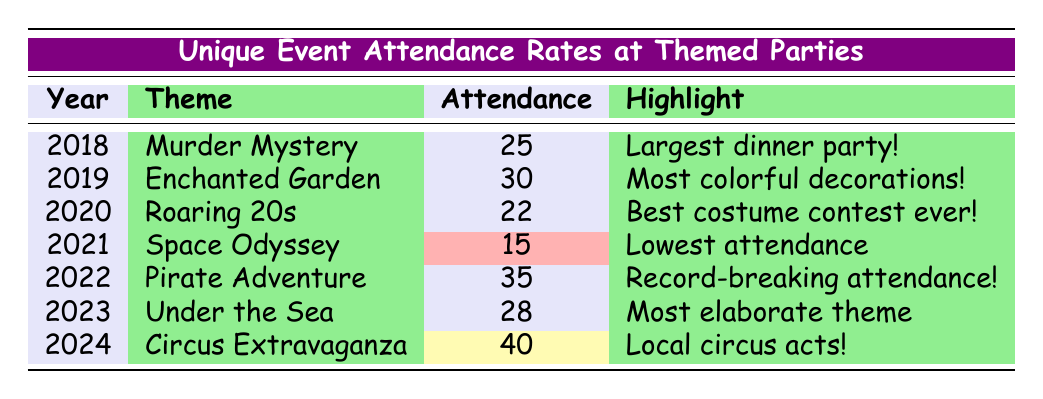What was the attendance at Aunt Margie's Enchanted Soirée in 2019? The table lists the attendance for the event "Aunt Margie's Enchanted Soirée" in the year 2019, which is 30.
Answer: 30 Which themed party had the lowest attendance? The "Space Odyssey" themed party in 2021 had the lowest attendance with a count of 15, which is highlighted in red.
Answer: 15 What is the total attendance for the themed parties from 2018 to 2022? To find the total attendance, we add the attendees: 25 (2018) + 30 (2019) + 22 (2020) + 15 (2021) + 35 (2022) = 127.
Answer: 127 Did the attendance increase or decrease from the "Great Gatsby Gatsby Night" to the "Mermaid Masquerade"? "Great Gatsby Gatsby Night" had 22 attendees and "Mermaid Masquerade" had 28 attendees. The attendance increased from 22 to 28.
Answer: Increase What was the average attendance from the events listed from 2018 to 2024? Add the attendance figures: 25 + 30 + 22 + 15 + 35 + 28 + 40 = 195. There are 7 events, so the average attendance is 195 / 7 ≈ 27.857, which rounds to approximately 28.
Answer: 28 Which themed party had the highest attendance and what was the specific number? The "Circus Extravaganza" in 2024 had the highest attendance with 40, which is highlighted in yellow.
Answer: 40 Was there any event in the table that had an attendance less than 20? Checking the attendance figures: the lowest is 15 for the "Space Odyssey" theme, confirming that there is an event with attendance less than 20.
Answer: Yes What was the attendance difference between the "Pirate Adventure" and the "Enchanted Garden"? The attendance for "Pirate Adventure" is 35 and for "Enchanted Garden" is 30. The difference is 35 - 30 = 5.
Answer: 5 How many years listed had an attendance of more than 30? The "Enchanted Garden" (30), "Pirate Adventure" (35), and "Circus Extravaganza" (40) events had the attendance of more than 30, totaling 3 years.
Answer: 3 What notable feature was highlighted for the attendance of 40 in 2024? The "Circus Extravaganza" in 2024 was highlighted for having "Exciting performances by local circus acts!"
Answer: Exciting performances by local circus acts! 